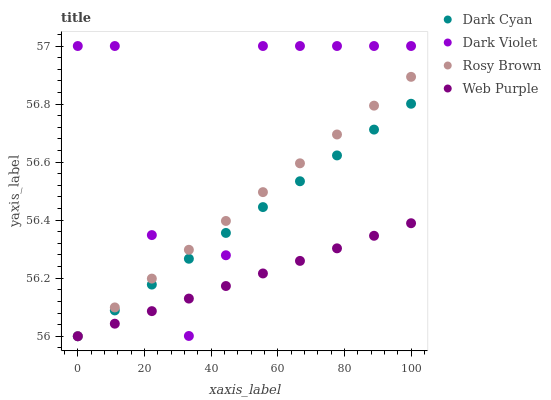Does Web Purple have the minimum area under the curve?
Answer yes or no. Yes. Does Dark Violet have the maximum area under the curve?
Answer yes or no. Yes. Does Rosy Brown have the minimum area under the curve?
Answer yes or no. No. Does Rosy Brown have the maximum area under the curve?
Answer yes or no. No. Is Dark Cyan the smoothest?
Answer yes or no. Yes. Is Dark Violet the roughest?
Answer yes or no. Yes. Is Web Purple the smoothest?
Answer yes or no. No. Is Web Purple the roughest?
Answer yes or no. No. Does Dark Cyan have the lowest value?
Answer yes or no. Yes. Does Dark Violet have the lowest value?
Answer yes or no. No. Does Dark Violet have the highest value?
Answer yes or no. Yes. Does Rosy Brown have the highest value?
Answer yes or no. No. Does Web Purple intersect Rosy Brown?
Answer yes or no. Yes. Is Web Purple less than Rosy Brown?
Answer yes or no. No. Is Web Purple greater than Rosy Brown?
Answer yes or no. No. 